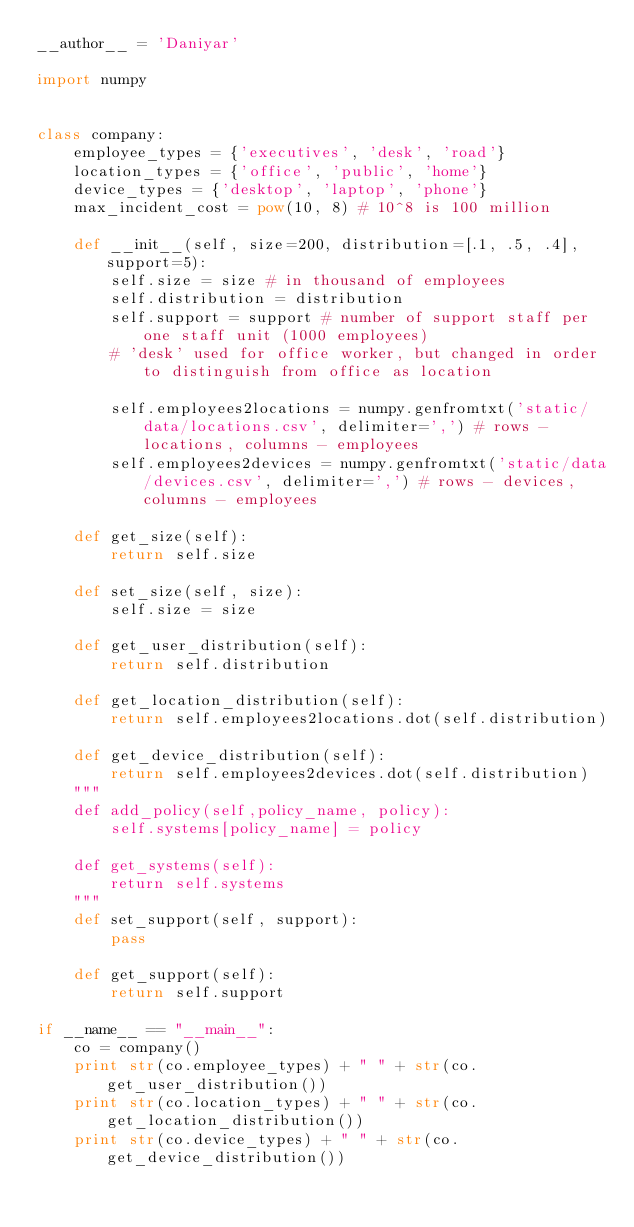Convert code to text. <code><loc_0><loc_0><loc_500><loc_500><_Python_>__author__ = 'Daniyar'

import numpy


class company:
    employee_types = {'executives', 'desk', 'road'}
    location_types = {'office', 'public', 'home'}
    device_types = {'desktop', 'laptop', 'phone'}
    max_incident_cost = pow(10, 8) # 10^8 is 100 million

    def __init__(self, size=200, distribution=[.1, .5, .4], support=5):
        self.size = size # in thousand of employees
        self.distribution = distribution
        self.support = support # number of support staff per one staff unit (1000 employees)
        # 'desk' used for office worker, but changed in order to distinguish from office as location

        self.employees2locations = numpy.genfromtxt('static/data/locations.csv', delimiter=',') # rows - locations, columns - employees
        self.employees2devices = numpy.genfromtxt('static/data/devices.csv', delimiter=',') # rows - devices, columns - employees

    def get_size(self):
        return self.size

    def set_size(self, size):
        self.size = size

    def get_user_distribution(self):
        return self.distribution

    def get_location_distribution(self):
        return self.employees2locations.dot(self.distribution)

    def get_device_distribution(self):
        return self.employees2devices.dot(self.distribution)
    """
    def add_policy(self,policy_name, policy):
        self.systems[policy_name] = policy

    def get_systems(self):
        return self.systems
    """
    def set_support(self, support):
        pass

    def get_support(self):
        return self.support

if __name__ == "__main__":
    co = company()
    print str(co.employee_types) + " " + str(co.get_user_distribution())
    print str(co.location_types) + " " + str(co.get_location_distribution())
    print str(co.device_types) + " " + str(co.get_device_distribution())
</code> 